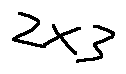<formula> <loc_0><loc_0><loc_500><loc_500>2 \times 3</formula> 